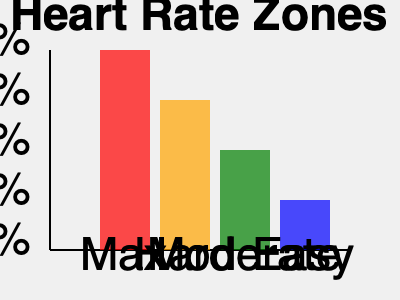As a teenager who uses physical activity to cope with stress and anxiety, you want to ensure you're exercising at the right intensity. Your maximum heart rate is 200 beats per minute (bpm). Using the heart rate zones chart, calculate the range of heart rates (in bpm) for the "Moderate" intensity zone. To calculate the heart rate range for the "Moderate" intensity zone, we'll follow these steps:

1. Identify the percentage range for the "Moderate" zone from the chart:
   The "Moderate" zone (green) ranges from 80% to 70% of maximum heart rate.

2. Calculate the upper limit of the "Moderate" zone:
   Upper limit = 80% of maximum heart rate
   $80\% \times 200 \text{ bpm} = 0.80 \times 200 = 160 \text{ bpm}$

3. Calculate the lower limit of the "Moderate" zone:
   Lower limit = 70% of maximum heart rate
   $70\% \times 200 \text{ bpm} = 0.70 \times 200 = 140 \text{ bpm}$

4. Express the range:
   The "Moderate" intensity zone ranges from 140 bpm to 160 bpm.

This range represents the ideal heart rate to maintain during moderate-intensity exercises, which can be effective for stress relief and anxiety management without overexertion.
Answer: 140-160 bpm 